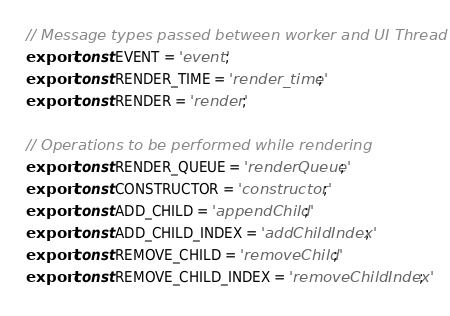<code> <loc_0><loc_0><loc_500><loc_500><_JavaScript_>// Message types passed between worker and UI Thread
export const EVENT = 'event';
export const RENDER_TIME = 'render_time';
export const RENDER = 'render';

// Operations to be performed while rendering
export const RENDER_QUEUE = 'renderQueue';
export const CONSTRUCTOR = 'constructor';
export const ADD_CHILD = 'appendChild'; 
export const ADD_CHILD_INDEX = 'addChildIndex'; 
export const REMOVE_CHILD = 'removeChild';
export const REMOVE_CHILD_INDEX = 'removeChildIndex';</code> 